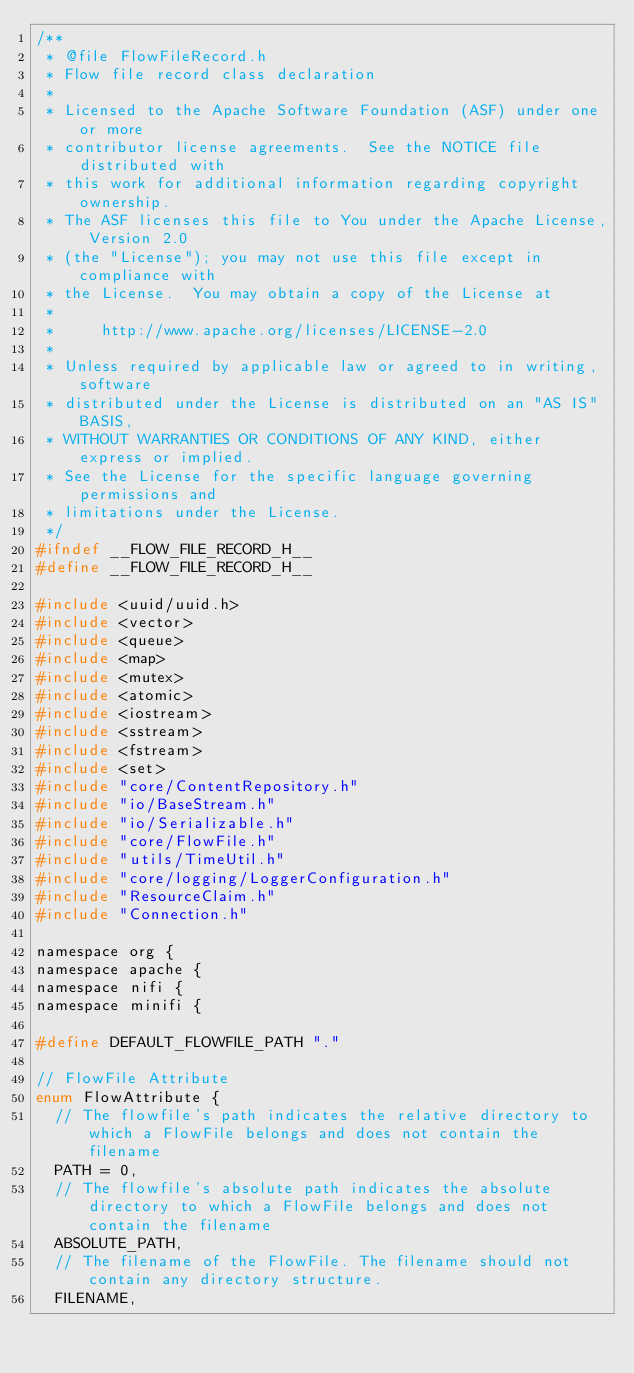<code> <loc_0><loc_0><loc_500><loc_500><_C_>/**
 * @file FlowFileRecord.h
 * Flow file record class declaration
 *
 * Licensed to the Apache Software Foundation (ASF) under one or more
 * contributor license agreements.  See the NOTICE file distributed with
 * this work for additional information regarding copyright ownership.
 * The ASF licenses this file to You under the Apache License, Version 2.0
 * (the "License"); you may not use this file except in compliance with
 * the License.  You may obtain a copy of the License at
 *
 *     http://www.apache.org/licenses/LICENSE-2.0
 *
 * Unless required by applicable law or agreed to in writing, software
 * distributed under the License is distributed on an "AS IS" BASIS,
 * WITHOUT WARRANTIES OR CONDITIONS OF ANY KIND, either express or implied.
 * See the License for the specific language governing permissions and
 * limitations under the License.
 */
#ifndef __FLOW_FILE_RECORD_H__
#define __FLOW_FILE_RECORD_H__

#include <uuid/uuid.h>
#include <vector>
#include <queue>
#include <map>
#include <mutex>
#include <atomic>
#include <iostream>
#include <sstream>
#include <fstream>
#include <set>
#include "core/ContentRepository.h"
#include "io/BaseStream.h"
#include "io/Serializable.h"
#include "core/FlowFile.h"
#include "utils/TimeUtil.h"
#include "core/logging/LoggerConfiguration.h"
#include "ResourceClaim.h"
#include "Connection.h"

namespace org {
namespace apache {
namespace nifi {
namespace minifi {

#define DEFAULT_FLOWFILE_PATH "."

// FlowFile Attribute
enum FlowAttribute {
  // The flowfile's path indicates the relative directory to which a FlowFile belongs and does not contain the filename
  PATH = 0,
  // The flowfile's absolute path indicates the absolute directory to which a FlowFile belongs and does not contain the filename
  ABSOLUTE_PATH,
  // The filename of the FlowFile. The filename should not contain any directory structure.
  FILENAME,</code> 